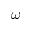Convert formula to latex. <formula><loc_0><loc_0><loc_500><loc_500>\omega</formula> 